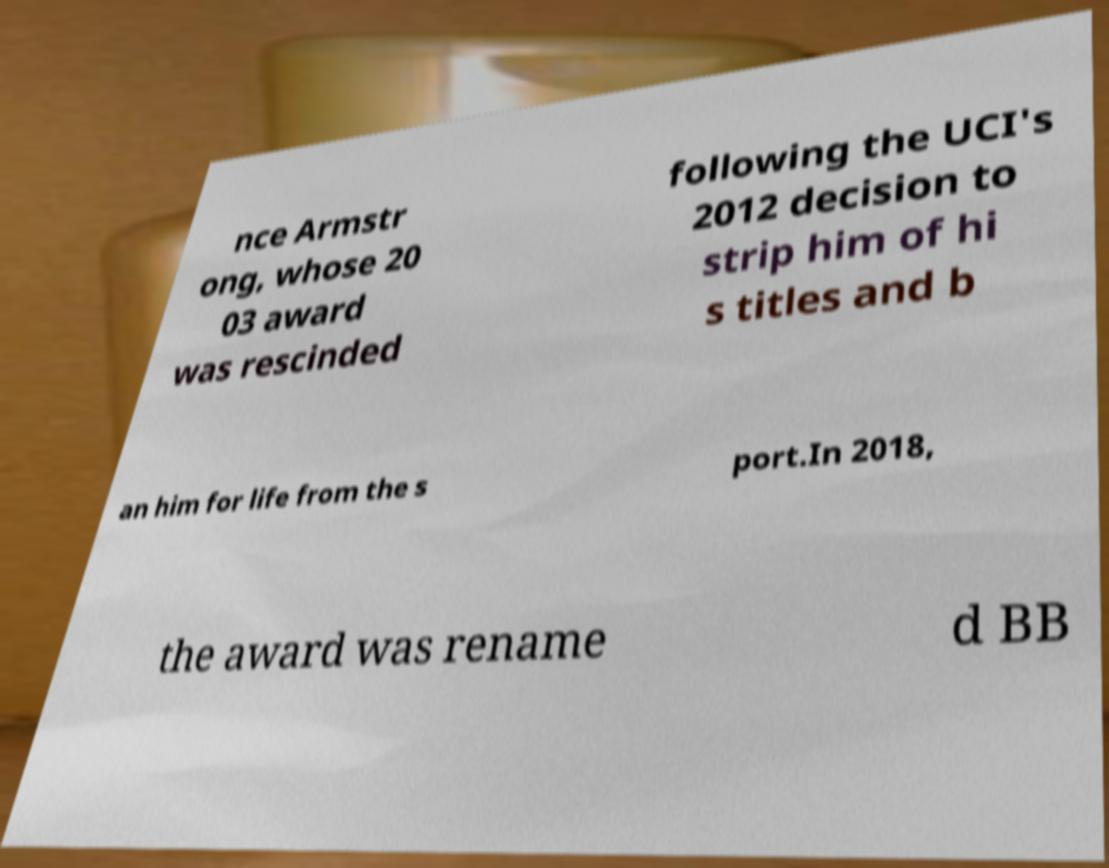Could you assist in decoding the text presented in this image and type it out clearly? nce Armstr ong, whose 20 03 award was rescinded following the UCI's 2012 decision to strip him of hi s titles and b an him for life from the s port.In 2018, the award was rename d BB 